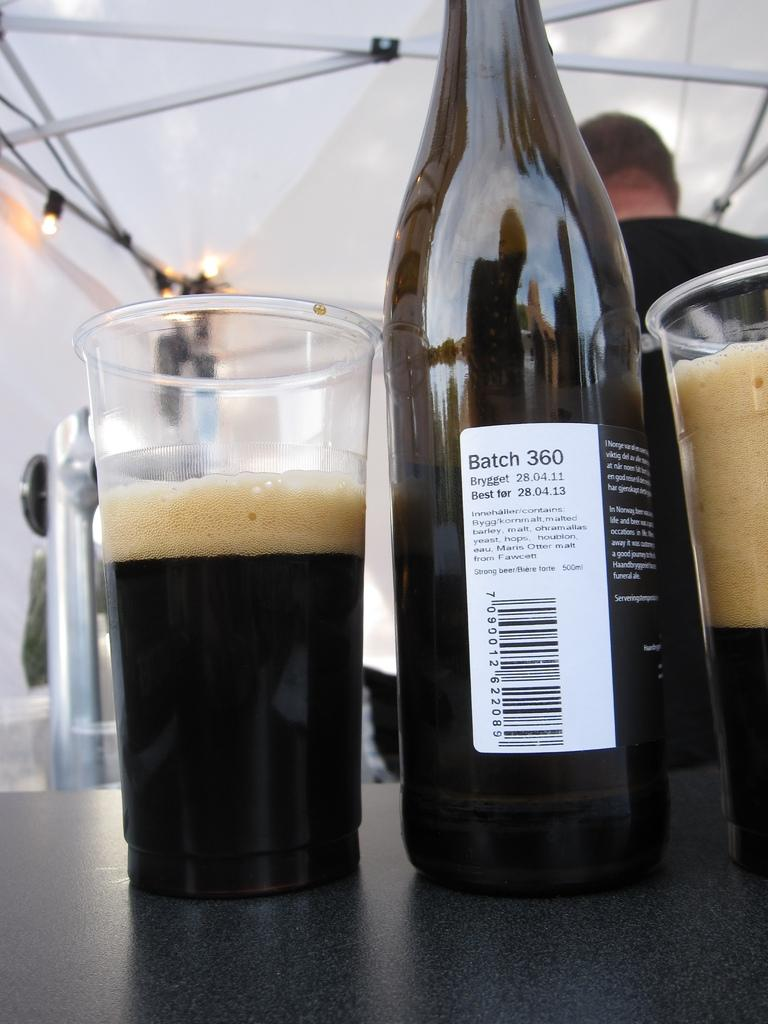What can be seen in the image that contains a liquid? There is a bottle and glasses with a drink in the image. Where are the bottle and glasses located? The bottle and glasses are on a platform. What can be seen in the background of the image? There is a person, lights, rods, and a tent visible in the background. What is the cent's reaction to the drink in the image? There is no cent present in the image, so it is not possible to determine its reaction to the drink. 